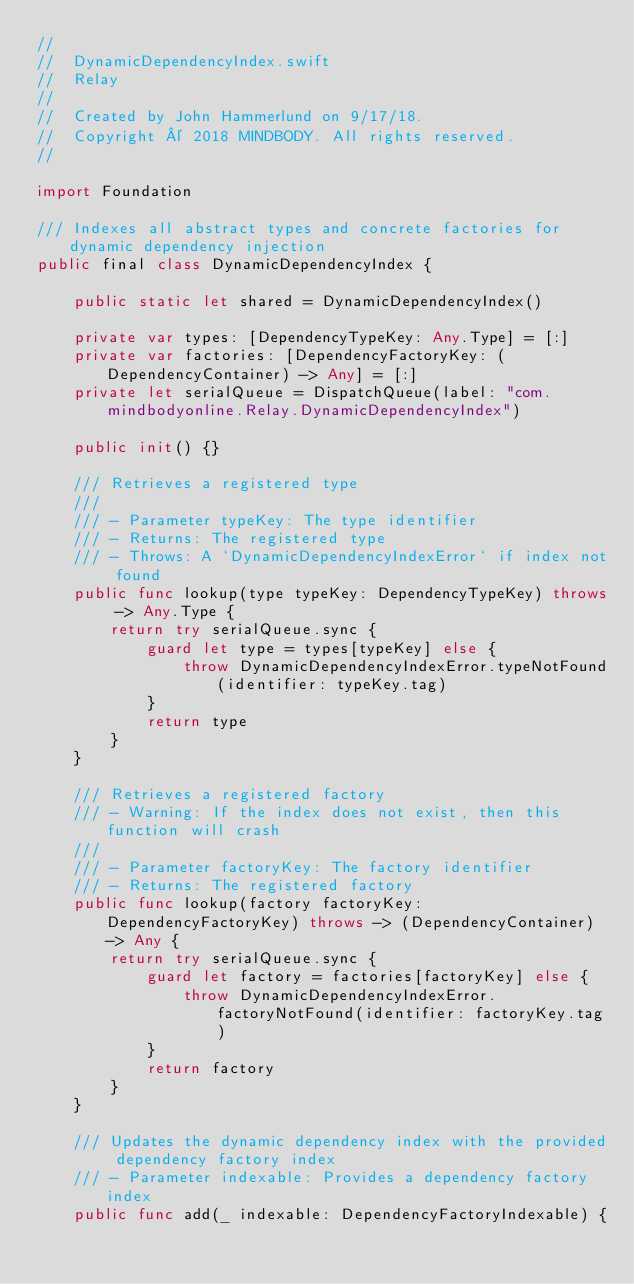Convert code to text. <code><loc_0><loc_0><loc_500><loc_500><_Swift_>//
//  DynamicDependencyIndex.swift
//  Relay
//
//  Created by John Hammerlund on 9/17/18.
//  Copyright © 2018 MINDBODY. All rights reserved.
//

import Foundation

/// Indexes all abstract types and concrete factories for dynamic dependency injection
public final class DynamicDependencyIndex {

    public static let shared = DynamicDependencyIndex()

    private var types: [DependencyTypeKey: Any.Type] = [:]
    private var factories: [DependencyFactoryKey: (DependencyContainer) -> Any] = [:]
    private let serialQueue = DispatchQueue(label: "com.mindbodyonline.Relay.DynamicDependencyIndex")

    public init() {}

    /// Retrieves a registered type
    ///
    /// - Parameter typeKey: The type identifier
    /// - Returns: The registered type
    /// - Throws: A `DynamicDependencyIndexError` if index not found
    public func lookup(type typeKey: DependencyTypeKey) throws -> Any.Type {
        return try serialQueue.sync {
            guard let type = types[typeKey] else {
                throw DynamicDependencyIndexError.typeNotFound(identifier: typeKey.tag)
            }
            return type
        }
    }

    /// Retrieves a registered factory
    /// - Warning: If the index does not exist, then this function will crash
    ///
    /// - Parameter factoryKey: The factory identifier
    /// - Returns: The registered factory
    public func lookup(factory factoryKey: DependencyFactoryKey) throws -> (DependencyContainer) -> Any {
        return try serialQueue.sync {
            guard let factory = factories[factoryKey] else {
                throw DynamicDependencyIndexError.factoryNotFound(identifier: factoryKey.tag)
            }
            return factory
        }
    }

    /// Updates the dynamic dependency index with the provided dependency factory index
    /// - Parameter indexable: Provides a dependency factory index
    public func add(_ indexable: DependencyFactoryIndexable) {</code> 